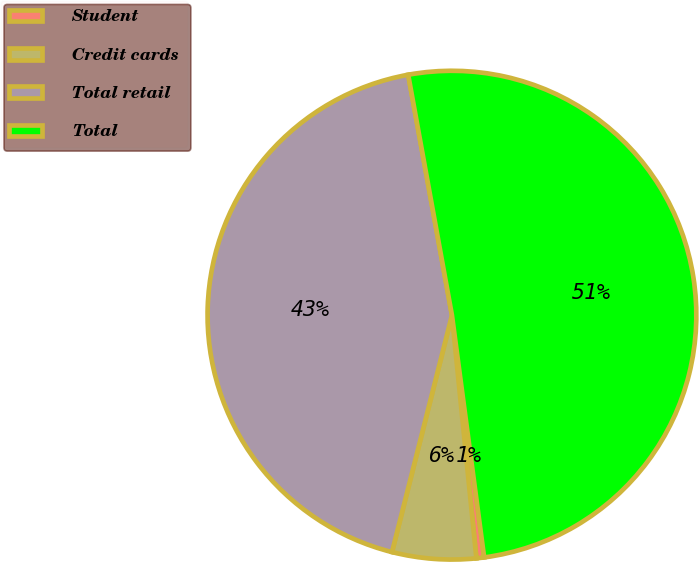<chart> <loc_0><loc_0><loc_500><loc_500><pie_chart><fcel>Student<fcel>Credit cards<fcel>Total retail<fcel>Total<nl><fcel>0.51%<fcel>5.54%<fcel>43.19%<fcel>50.76%<nl></chart> 